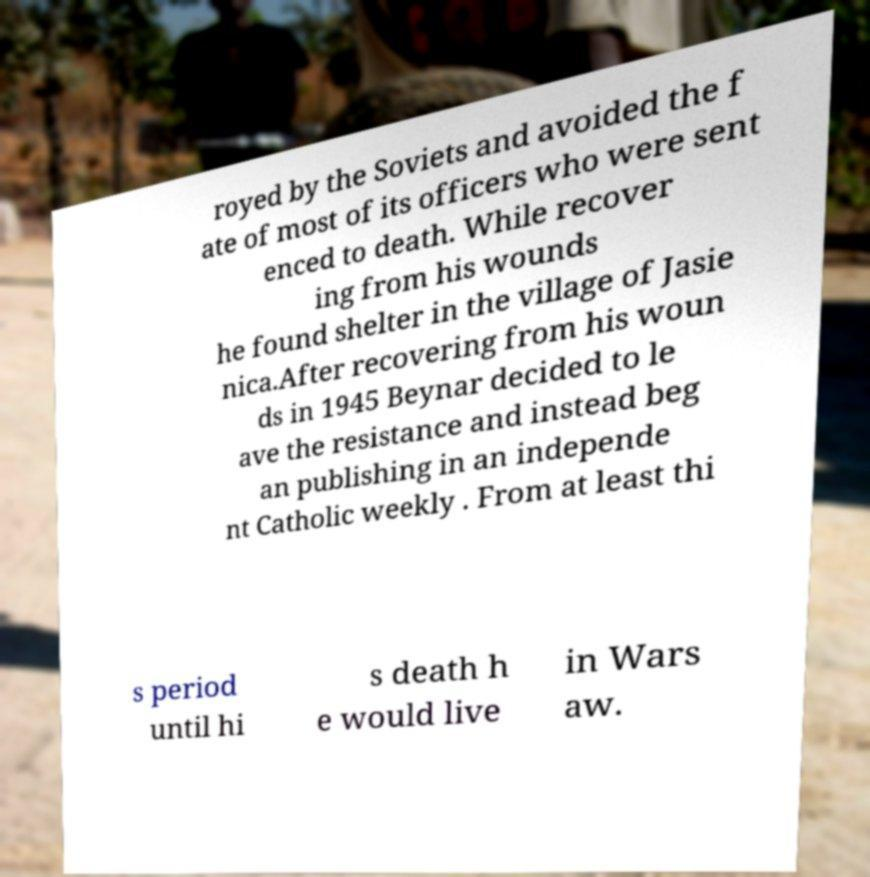Can you read and provide the text displayed in the image?This photo seems to have some interesting text. Can you extract and type it out for me? royed by the Soviets and avoided the f ate of most of its officers who were sent enced to death. While recover ing from his wounds he found shelter in the village of Jasie nica.After recovering from his woun ds in 1945 Beynar decided to le ave the resistance and instead beg an publishing in an independe nt Catholic weekly . From at least thi s period until hi s death h e would live in Wars aw. 